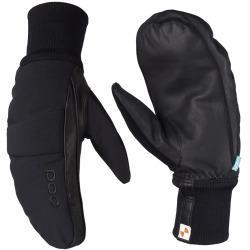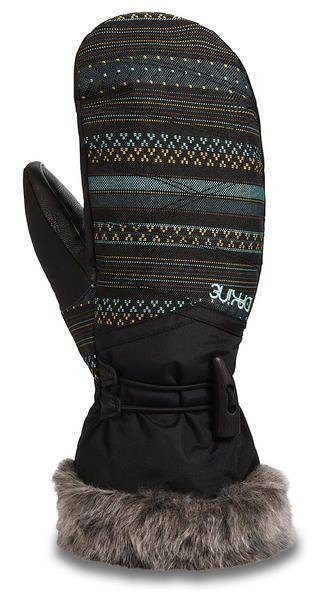The first image is the image on the left, the second image is the image on the right. Evaluate the accuracy of this statement regarding the images: "Mittens are decorated with fur/faux fur and contain colors other than black.". Is it true? Answer yes or no. Yes. 